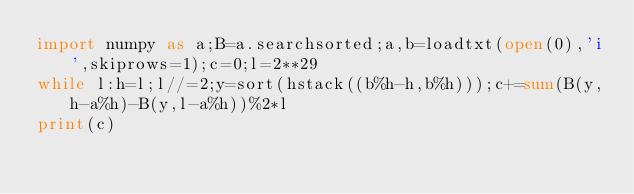Convert code to text. <code><loc_0><loc_0><loc_500><loc_500><_Python_>import numpy as a;B=a.searchsorted;a,b=loadtxt(open(0),'i',skiprows=1);c=0;l=2**29
while l:h=l;l//=2;y=sort(hstack((b%h-h,b%h)));c+=sum(B(y,h-a%h)-B(y,l-a%h))%2*l
print(c)
</code> 